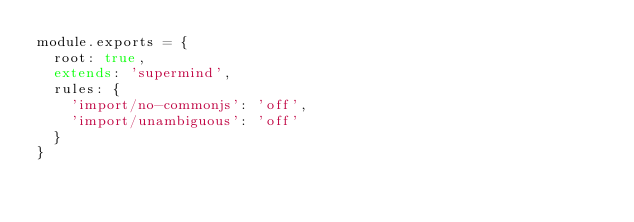<code> <loc_0><loc_0><loc_500><loc_500><_JavaScript_>module.exports = {
  root: true,
  extends: 'supermind',
  rules: {
    'import/no-commonjs': 'off',
    'import/unambiguous': 'off'
  }
}
</code> 